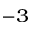<formula> <loc_0><loc_0><loc_500><loc_500>^ { - 3 }</formula> 